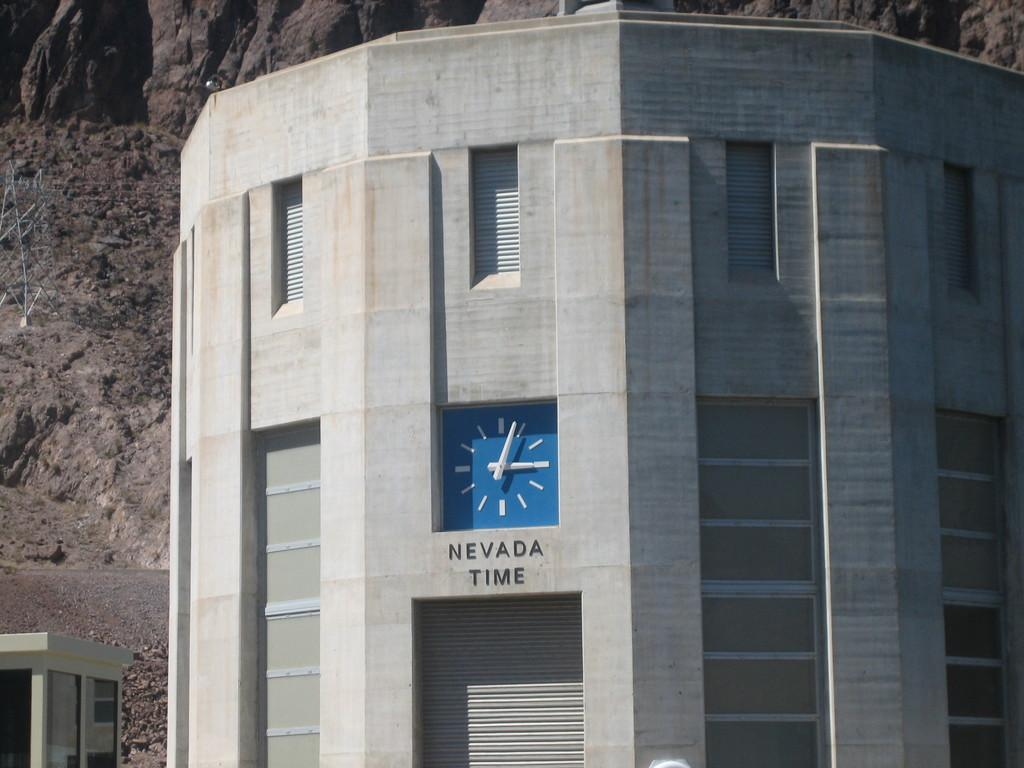<image>
Relay a brief, clear account of the picture shown. Gray building with a blue cock and the words "Nevada Time". 